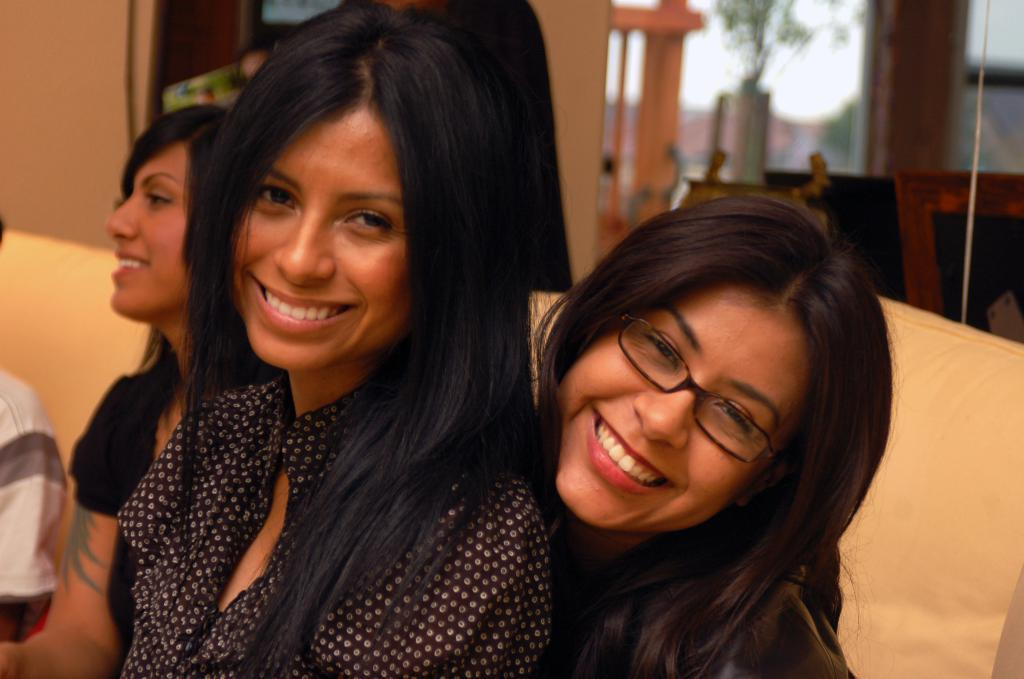How many women are in the image? There are three women in the image. What are the women doing in the image? The women are sitting on a couch and smiling. What can be seen in the background of the image? There is a wall in the background of the image, and there are plants to the right of the image. How would you describe the quality of the background in the image? The background is blurry. What type of horse is visible in the image? There is no horse present in the image. What role does the mom play in the image? There is no mention of a mom in the image, as it features three women who are not identified as mothers. 